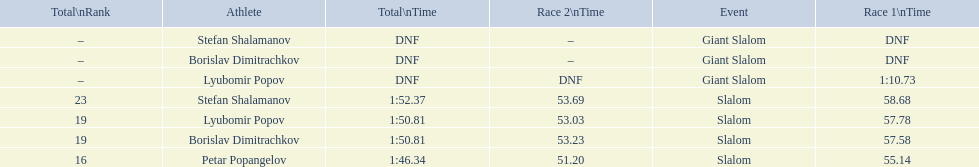Which athlete had a race time above 1:00? Lyubomir Popov. 